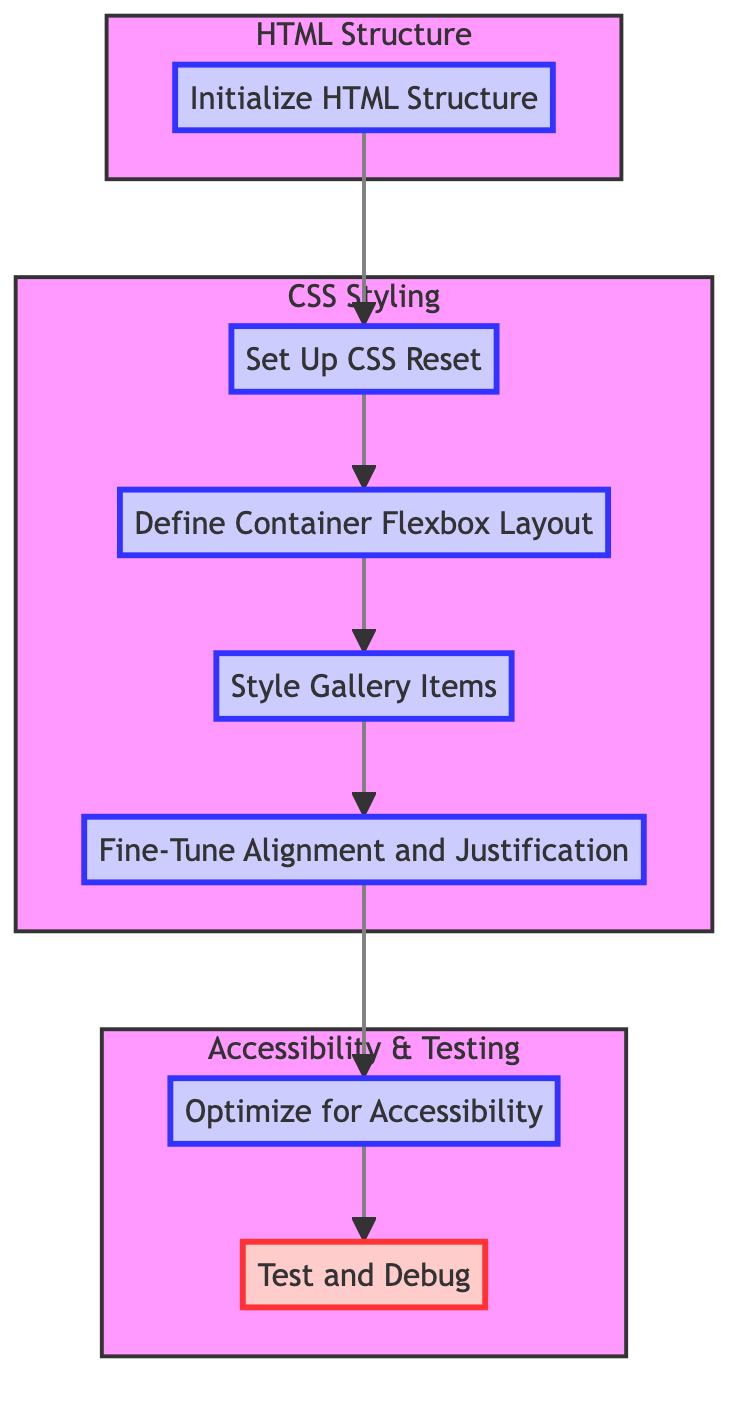What is the first step in the flowchart? The flowchart starts with the first step labeled "Initialize HTML Structure." It is the first node before any other steps.
Answer: Initialize HTML Structure How many steps are defined in the diagram? Counting each step node, there are a total of seven steps in the flowchart as shown in the sequence from step one to step seven.
Answer: Seven Which step directly follows "Set Up CSS Reset"? Following the step labeled "Set Up CSS Reset," the next step is "Define Container Flexbox Layout," as indicated by the directed arrow from the second to third node.
Answer: Define Container Flexbox Layout What is the role of the "Optimize for Accessibility" step in the diagram? "Optimize for Accessibility" is the sixth step, aimed at ensuring the gallery is accessible, as outlined in its description and positioned within its group in the flowchart.
Answer: Ensure accessibility Which subgraph contains the step for "Test and Debug"? The step for "Test and Debug" is located in the subgraph labeled "Accessibility & Testing," as this subgraph includes the last two steps that focus on testing and accessibility.
Answer: Accessibility & Testing What are the two types of elements shown in the flowchart? The flowchart includes steps for creating HTML structure and applying CSS styling as distinct types of elements represented by the subgraphs.
Answer: HTML Structure, CSS Styling How is the visual emphasis provided for the last step in the flowchart? The last step, "Test and Debug," is visually emphasized by being within an emphasized style class that makes it prominent compared to other steps within the diagram.
Answer: Emphasized style class 